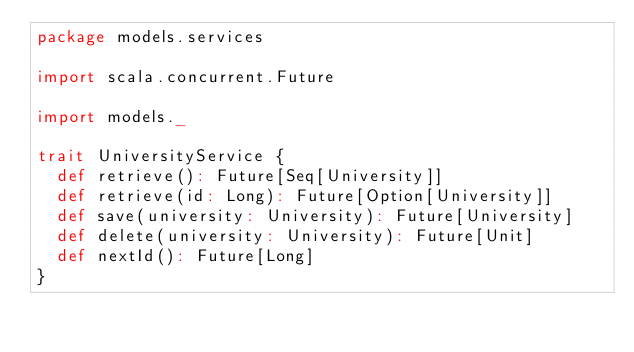<code> <loc_0><loc_0><loc_500><loc_500><_Scala_>package models.services

import scala.concurrent.Future

import models._

trait UniversityService {
  def retrieve(): Future[Seq[University]]
  def retrieve(id: Long): Future[Option[University]]
  def save(university: University): Future[University]
  def delete(university: University): Future[Unit]
  def nextId(): Future[Long]
}
</code> 